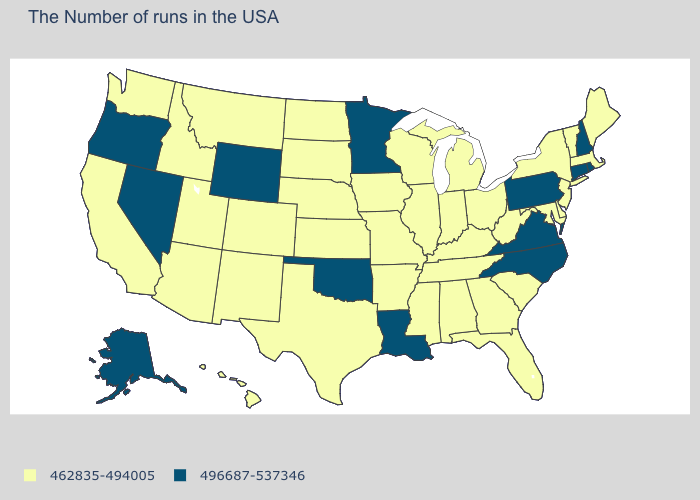How many symbols are there in the legend?
Concise answer only. 2. Name the states that have a value in the range 496687-537346?
Be succinct. Rhode Island, New Hampshire, Connecticut, Pennsylvania, Virginia, North Carolina, Louisiana, Minnesota, Oklahoma, Wyoming, Nevada, Oregon, Alaska. How many symbols are there in the legend?
Be succinct. 2. How many symbols are there in the legend?
Be succinct. 2. What is the value of New Jersey?
Write a very short answer. 462835-494005. Name the states that have a value in the range 496687-537346?
Quick response, please. Rhode Island, New Hampshire, Connecticut, Pennsylvania, Virginia, North Carolina, Louisiana, Minnesota, Oklahoma, Wyoming, Nevada, Oregon, Alaska. How many symbols are there in the legend?
Be succinct. 2. What is the lowest value in the Northeast?
Concise answer only. 462835-494005. Does Utah have a lower value than Virginia?
Write a very short answer. Yes. Which states have the highest value in the USA?
Be succinct. Rhode Island, New Hampshire, Connecticut, Pennsylvania, Virginia, North Carolina, Louisiana, Minnesota, Oklahoma, Wyoming, Nevada, Oregon, Alaska. Does Minnesota have the lowest value in the MidWest?
Write a very short answer. No. Which states have the highest value in the USA?
Answer briefly. Rhode Island, New Hampshire, Connecticut, Pennsylvania, Virginia, North Carolina, Louisiana, Minnesota, Oklahoma, Wyoming, Nevada, Oregon, Alaska. What is the value of Colorado?
Answer briefly. 462835-494005. What is the value of Florida?
Write a very short answer. 462835-494005. Does California have the highest value in the USA?
Concise answer only. No. 